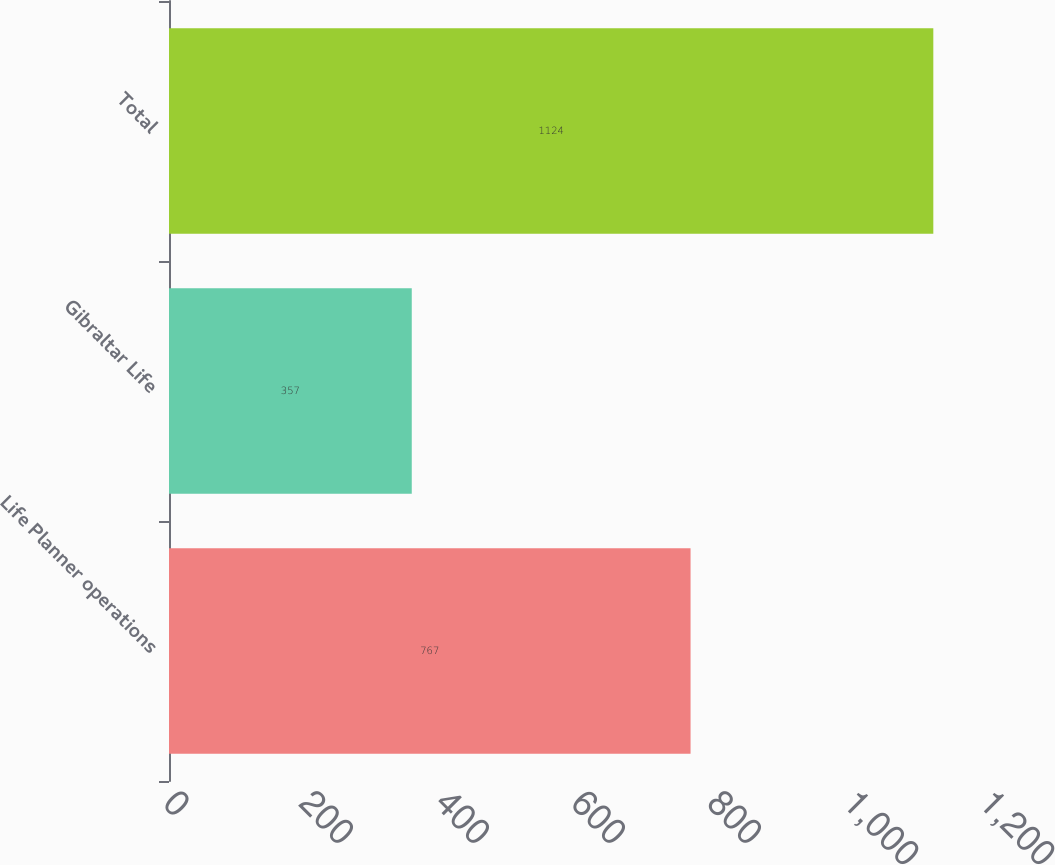Convert chart. <chart><loc_0><loc_0><loc_500><loc_500><bar_chart><fcel>Life Planner operations<fcel>Gibraltar Life<fcel>Total<nl><fcel>767<fcel>357<fcel>1124<nl></chart> 